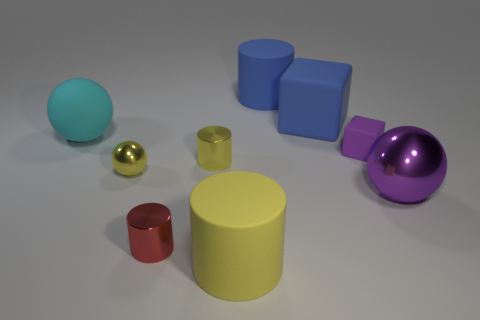There is a sphere that is behind the yellow shiny ball; is it the same size as the metal ball that is behind the purple sphere?
Make the answer very short. No. What number of objects are small purple objects or matte objects that are to the right of the tiny red metal cylinder?
Your response must be concise. 4. What is the size of the matte cylinder that is in front of the small metal sphere?
Provide a short and direct response. Large. Is the number of large matte spheres that are on the right side of the small yellow cylinder less than the number of small things to the right of the big blue cylinder?
Give a very brief answer. Yes. There is a thing that is both left of the purple shiny sphere and right of the big blue cube; what material is it?
Offer a very short reply. Rubber. There is a tiny yellow object in front of the yellow metal thing that is right of the yellow metallic sphere; what shape is it?
Give a very brief answer. Sphere. Do the large metal thing and the tiny matte block have the same color?
Your answer should be compact. Yes. How many red objects are either large balls or small cubes?
Offer a terse response. 0. There is a red cylinder; are there any big objects behind it?
Keep it short and to the point. Yes. How big is the blue cylinder?
Provide a short and direct response. Large. 